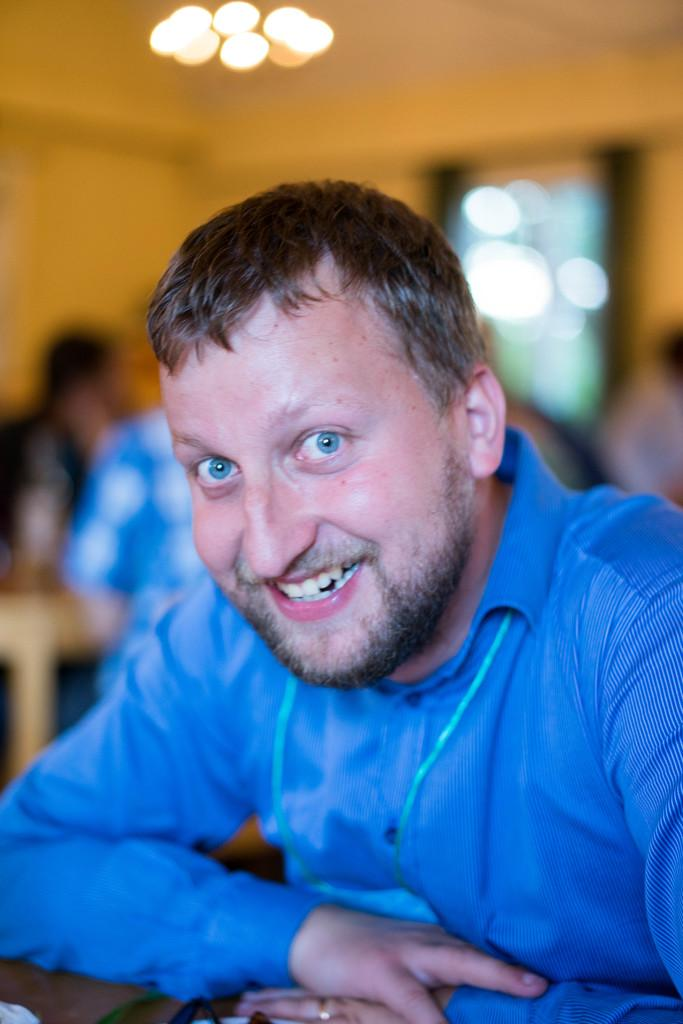What is the man in the image doing? The man is seated in the image. What expression does the man have? The man is smiling. What color is the shirt the man is wearing? The man is wearing a blue shirt. What can be seen on the table in the image? There is a table in the image, but the facts do not specify what is on it. What is visible in the background of the image? There are people visible in the background of the image. What is on the roof in the image? There are lights on the roof in the image. What type of cake is the man's pet eating in the image? There is no cake or pet present in the image. Where is the basin located in the image? The facts do not mention a basin in the image. 